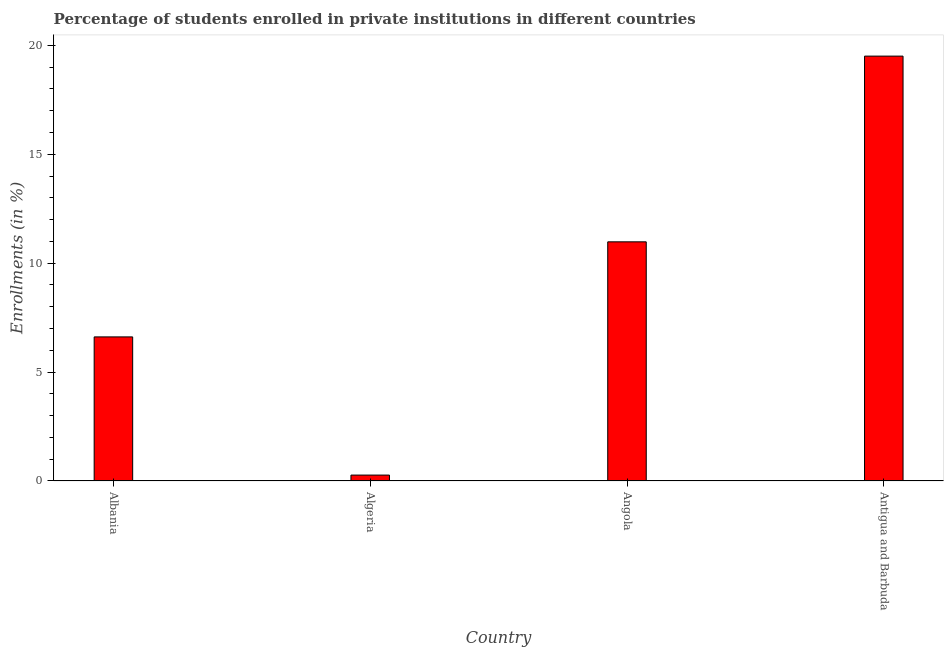What is the title of the graph?
Give a very brief answer. Percentage of students enrolled in private institutions in different countries. What is the label or title of the X-axis?
Ensure brevity in your answer.  Country. What is the label or title of the Y-axis?
Provide a succinct answer. Enrollments (in %). What is the enrollments in private institutions in Antigua and Barbuda?
Make the answer very short. 19.51. Across all countries, what is the maximum enrollments in private institutions?
Offer a terse response. 19.51. Across all countries, what is the minimum enrollments in private institutions?
Keep it short and to the point. 0.27. In which country was the enrollments in private institutions maximum?
Your answer should be compact. Antigua and Barbuda. In which country was the enrollments in private institutions minimum?
Your answer should be very brief. Algeria. What is the sum of the enrollments in private institutions?
Provide a succinct answer. 37.37. What is the difference between the enrollments in private institutions in Algeria and Angola?
Offer a terse response. -10.71. What is the average enrollments in private institutions per country?
Provide a succinct answer. 9.34. What is the median enrollments in private institutions?
Offer a terse response. 8.8. In how many countries, is the enrollments in private institutions greater than 12 %?
Provide a succinct answer. 1. What is the ratio of the enrollments in private institutions in Algeria to that in Angola?
Offer a terse response. 0.03. Is the difference between the enrollments in private institutions in Angola and Antigua and Barbuda greater than the difference between any two countries?
Offer a terse response. No. What is the difference between the highest and the second highest enrollments in private institutions?
Ensure brevity in your answer.  8.53. Is the sum of the enrollments in private institutions in Algeria and Antigua and Barbuda greater than the maximum enrollments in private institutions across all countries?
Provide a short and direct response. Yes. What is the difference between the highest and the lowest enrollments in private institutions?
Make the answer very short. 19.23. How many bars are there?
Your answer should be compact. 4. What is the Enrollments (in %) in Albania?
Provide a succinct answer. 6.61. What is the Enrollments (in %) in Algeria?
Keep it short and to the point. 0.27. What is the Enrollments (in %) of Angola?
Offer a very short reply. 10.98. What is the Enrollments (in %) in Antigua and Barbuda?
Provide a short and direct response. 19.51. What is the difference between the Enrollments (in %) in Albania and Algeria?
Your answer should be very brief. 6.34. What is the difference between the Enrollments (in %) in Albania and Angola?
Keep it short and to the point. -4.36. What is the difference between the Enrollments (in %) in Albania and Antigua and Barbuda?
Your response must be concise. -12.89. What is the difference between the Enrollments (in %) in Algeria and Angola?
Make the answer very short. -10.71. What is the difference between the Enrollments (in %) in Algeria and Antigua and Barbuda?
Your answer should be compact. -19.23. What is the difference between the Enrollments (in %) in Angola and Antigua and Barbuda?
Offer a very short reply. -8.53. What is the ratio of the Enrollments (in %) in Albania to that in Algeria?
Keep it short and to the point. 24.37. What is the ratio of the Enrollments (in %) in Albania to that in Angola?
Provide a short and direct response. 0.6. What is the ratio of the Enrollments (in %) in Albania to that in Antigua and Barbuda?
Give a very brief answer. 0.34. What is the ratio of the Enrollments (in %) in Algeria to that in Angola?
Provide a short and direct response. 0.03. What is the ratio of the Enrollments (in %) in Algeria to that in Antigua and Barbuda?
Give a very brief answer. 0.01. What is the ratio of the Enrollments (in %) in Angola to that in Antigua and Barbuda?
Provide a short and direct response. 0.56. 